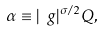Convert formula to latex. <formula><loc_0><loc_0><loc_500><loc_500>\alpha \equiv | \ g | ^ { \sigma / 2 } Q ,</formula> 